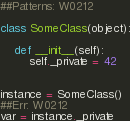<code> <loc_0><loc_0><loc_500><loc_500><_Python_>##Patterns: W0212

class SomeClass(object):

    def __init__(self):
        self._private = 42


instance = SomeClass()
##Err: W0212
var = instance._private
</code> 